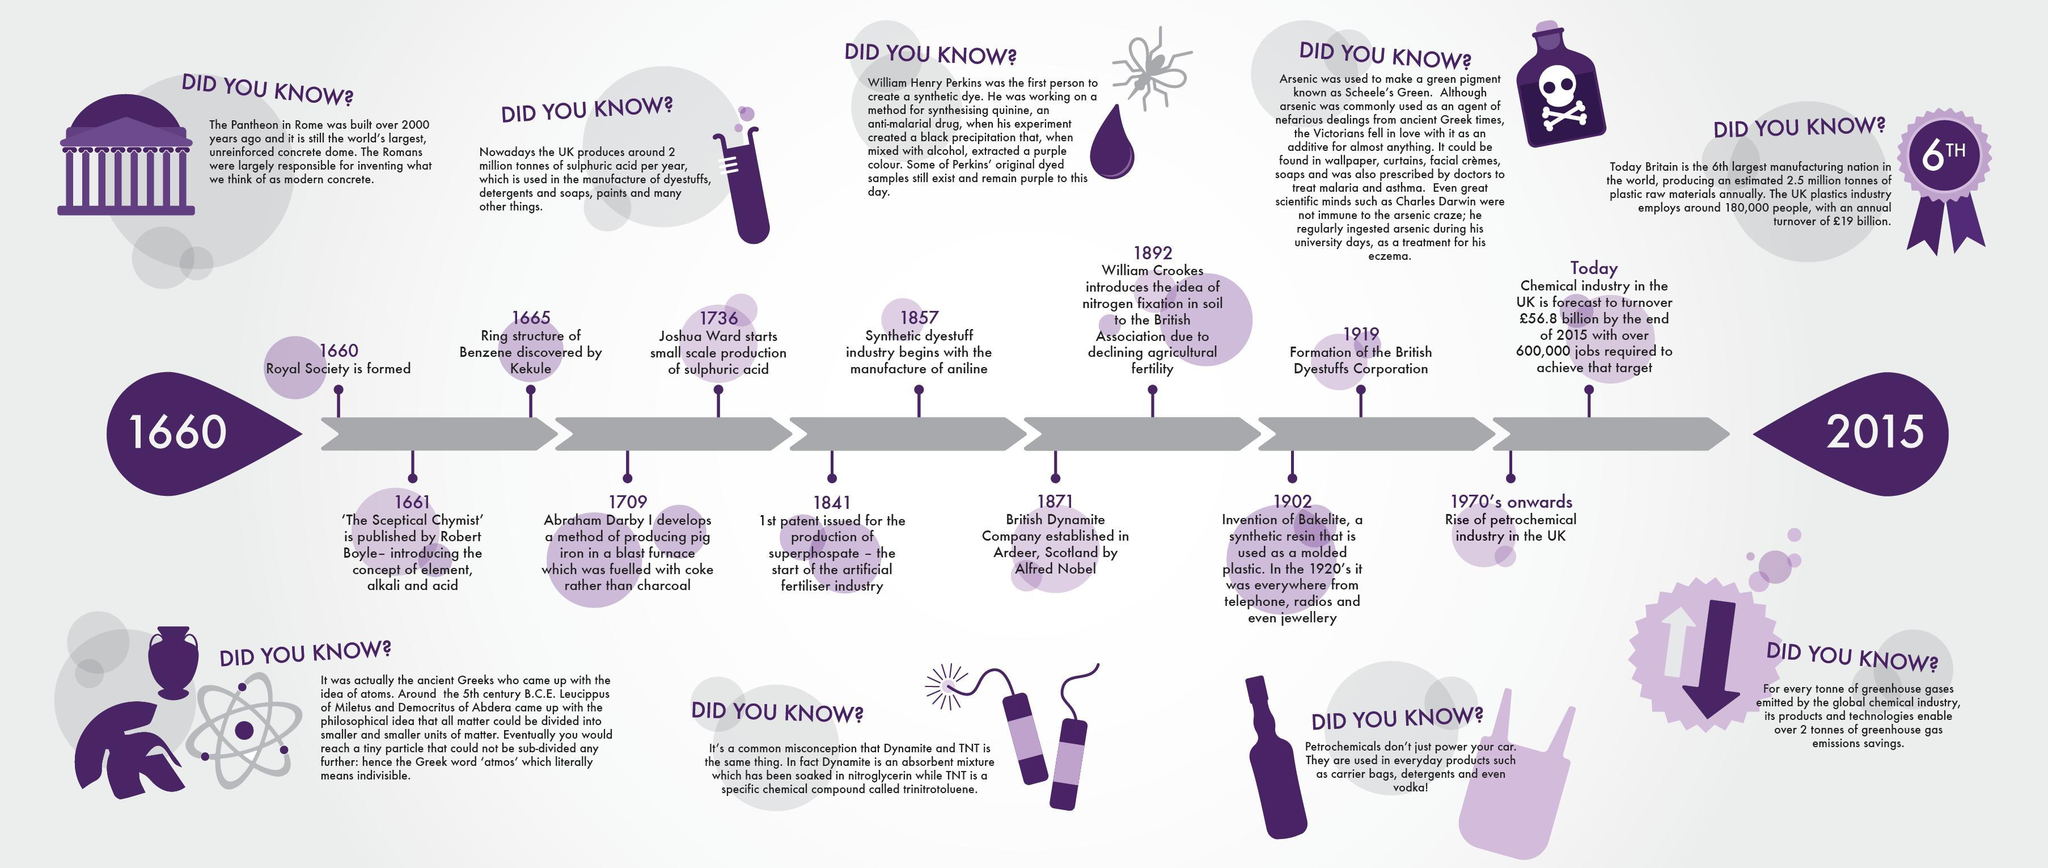Who discovered the ring structure of Benzene in 1665?
Answer the question with a short phrase. Kekule When was the rise of petrochemical industry took place in the UK? 1970's onwards When was the British Dyestuffs Corporation formed? 1919 When did Robert Boyle published the book 'The Sceptical Chymist'? 1661 Who established the British Dynamite Company in Scotland? Alfred Nobel 